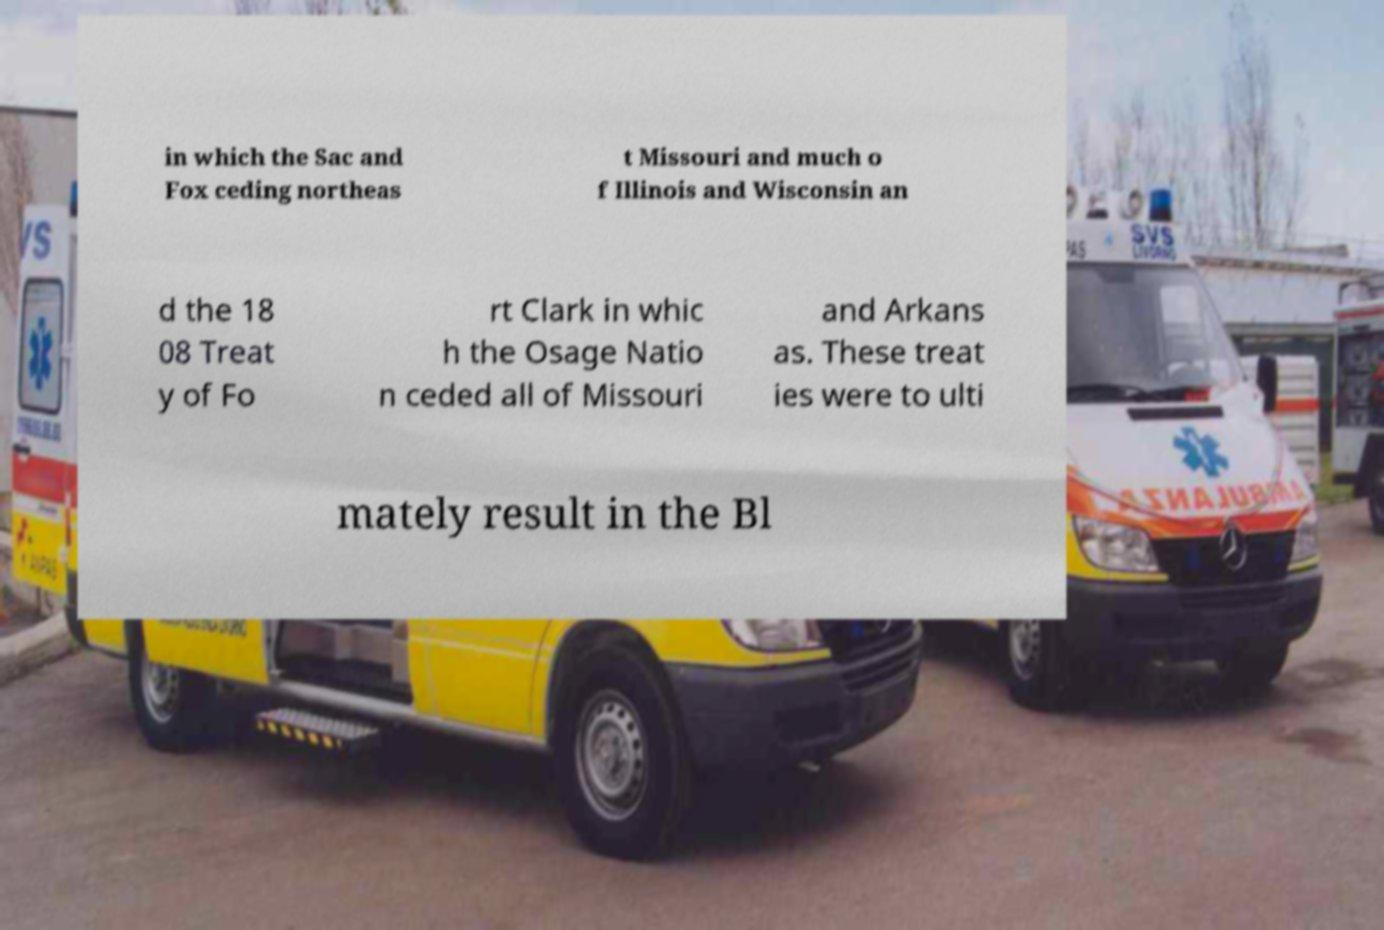For documentation purposes, I need the text within this image transcribed. Could you provide that? in which the Sac and Fox ceding northeas t Missouri and much o f Illinois and Wisconsin an d the 18 08 Treat y of Fo rt Clark in whic h the Osage Natio n ceded all of Missouri and Arkans as. These treat ies were to ulti mately result in the Bl 